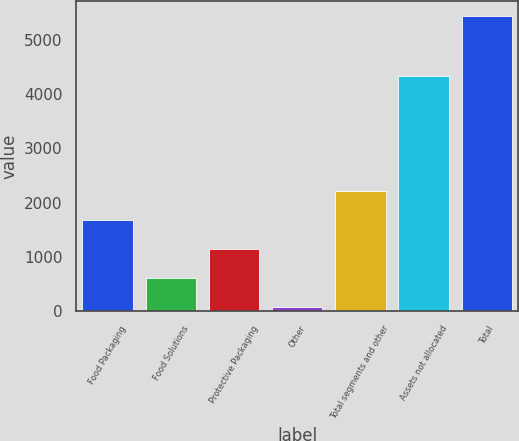<chart> <loc_0><loc_0><loc_500><loc_500><bar_chart><fcel>Food Packaging<fcel>Food Solutions<fcel>Protective Packaging<fcel>Other<fcel>Total segments and other<fcel>Assets not allocated<fcel>Total<nl><fcel>1680.14<fcel>606.38<fcel>1143.26<fcel>69.5<fcel>2217.02<fcel>4339.8<fcel>5438.3<nl></chart> 